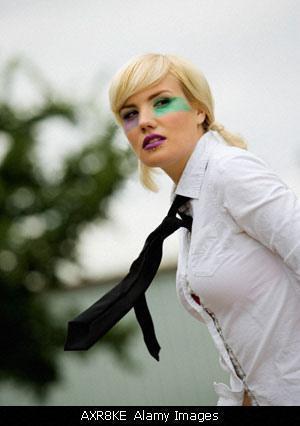How many ties are there?
Give a very brief answer. 1. How many people are there?
Give a very brief answer. 1. 